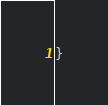<code> <loc_0><loc_0><loc_500><loc_500><_C#_>}</code> 